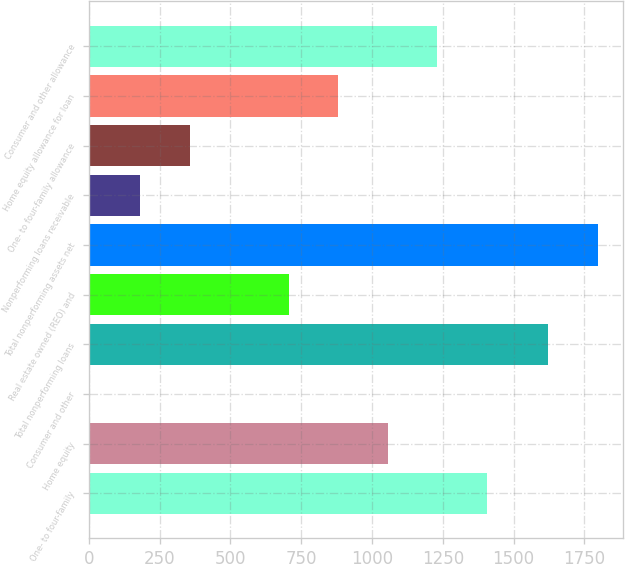Convert chart to OTSL. <chart><loc_0><loc_0><loc_500><loc_500><bar_chart><fcel>One- to four-family<fcel>Home equity<fcel>Consumer and other<fcel>Total nonperforming loans<fcel>Real estate owned (REO) and<fcel>Total nonperforming assets net<fcel>Nonperforming loans receivable<fcel>One- to four-family allowance<fcel>Home equity allowance for loan<fcel>Consumer and other allowance<nl><fcel>1405.9<fcel>1055.8<fcel>5.5<fcel>1622.5<fcel>705.7<fcel>1797.55<fcel>180.55<fcel>355.6<fcel>880.75<fcel>1230.85<nl></chart> 